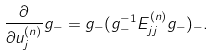Convert formula to latex. <formula><loc_0><loc_0><loc_500><loc_500>\frac { \partial } { \partial u _ { j } ^ { ( n ) } } g _ { - } = g _ { - } ( g _ { - } ^ { - 1 } E _ { j j } ^ { ( n ) } g _ { - } ) _ { - } .</formula> 